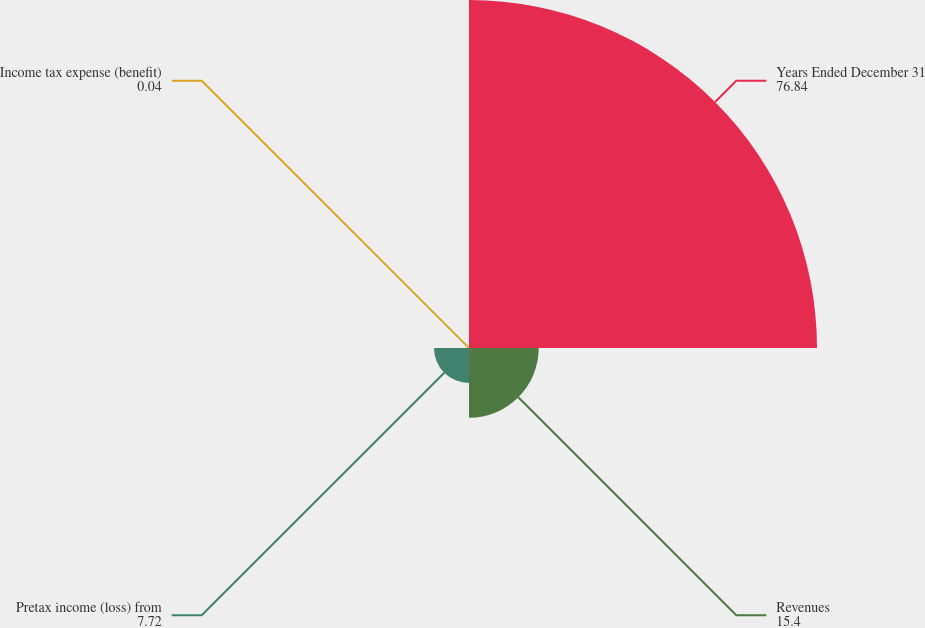Convert chart to OTSL. <chart><loc_0><loc_0><loc_500><loc_500><pie_chart><fcel>Years Ended December 31<fcel>Revenues<fcel>Pretax income (loss) from<fcel>Income tax expense (benefit)<nl><fcel>76.84%<fcel>15.4%<fcel>7.72%<fcel>0.04%<nl></chart> 